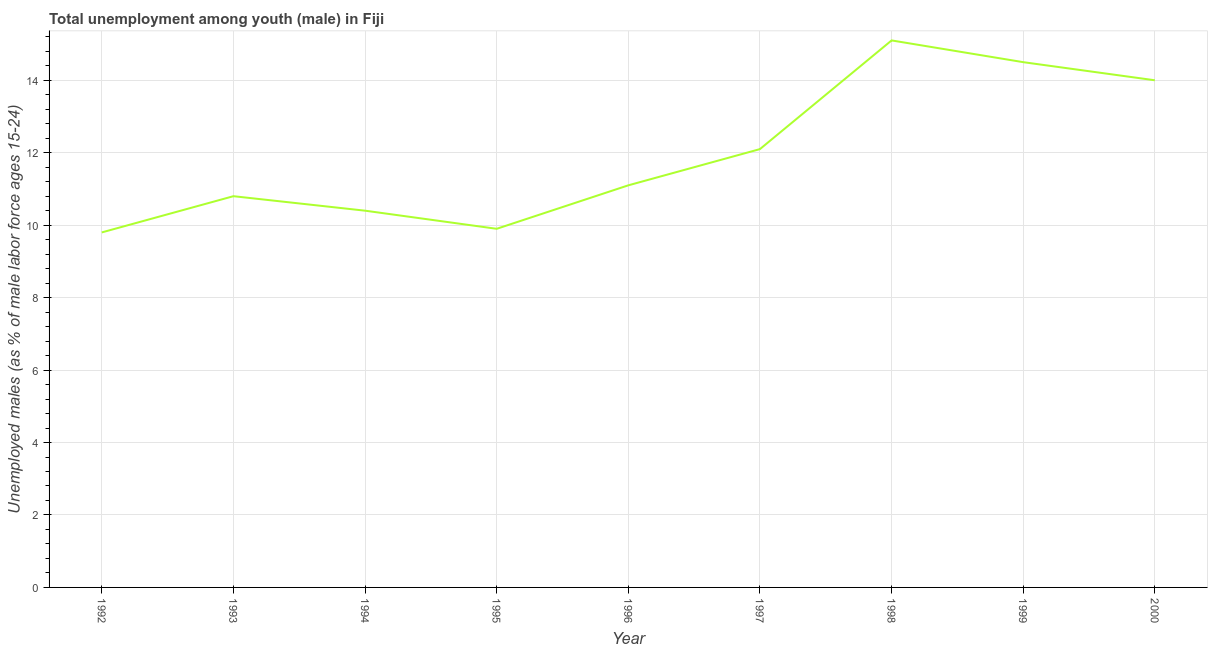What is the unemployed male youth population in 1992?
Make the answer very short. 9.8. Across all years, what is the maximum unemployed male youth population?
Offer a terse response. 15.1. Across all years, what is the minimum unemployed male youth population?
Give a very brief answer. 9.8. In which year was the unemployed male youth population maximum?
Provide a short and direct response. 1998. In which year was the unemployed male youth population minimum?
Your answer should be compact. 1992. What is the sum of the unemployed male youth population?
Your answer should be compact. 107.7. What is the difference between the unemployed male youth population in 1992 and 1994?
Your answer should be compact. -0.6. What is the average unemployed male youth population per year?
Offer a very short reply. 11.97. What is the median unemployed male youth population?
Provide a succinct answer. 11.1. What is the ratio of the unemployed male youth population in 1993 to that in 2000?
Your answer should be compact. 0.77. What is the difference between the highest and the second highest unemployed male youth population?
Offer a very short reply. 0.6. What is the difference between the highest and the lowest unemployed male youth population?
Give a very brief answer. 5.3. In how many years, is the unemployed male youth population greater than the average unemployed male youth population taken over all years?
Your answer should be very brief. 4. How many years are there in the graph?
Make the answer very short. 9. What is the difference between two consecutive major ticks on the Y-axis?
Provide a succinct answer. 2. Are the values on the major ticks of Y-axis written in scientific E-notation?
Provide a succinct answer. No. Does the graph contain any zero values?
Offer a terse response. No. What is the title of the graph?
Offer a terse response. Total unemployment among youth (male) in Fiji. What is the label or title of the Y-axis?
Ensure brevity in your answer.  Unemployed males (as % of male labor force ages 15-24). What is the Unemployed males (as % of male labor force ages 15-24) in 1992?
Your response must be concise. 9.8. What is the Unemployed males (as % of male labor force ages 15-24) in 1993?
Ensure brevity in your answer.  10.8. What is the Unemployed males (as % of male labor force ages 15-24) in 1994?
Your answer should be very brief. 10.4. What is the Unemployed males (as % of male labor force ages 15-24) of 1995?
Your response must be concise. 9.9. What is the Unemployed males (as % of male labor force ages 15-24) of 1996?
Your answer should be very brief. 11.1. What is the Unemployed males (as % of male labor force ages 15-24) in 1997?
Keep it short and to the point. 12.1. What is the Unemployed males (as % of male labor force ages 15-24) of 1998?
Your answer should be compact. 15.1. What is the difference between the Unemployed males (as % of male labor force ages 15-24) in 1992 and 1994?
Keep it short and to the point. -0.6. What is the difference between the Unemployed males (as % of male labor force ages 15-24) in 1992 and 1996?
Make the answer very short. -1.3. What is the difference between the Unemployed males (as % of male labor force ages 15-24) in 1992 and 1997?
Your answer should be very brief. -2.3. What is the difference between the Unemployed males (as % of male labor force ages 15-24) in 1992 and 1998?
Offer a very short reply. -5.3. What is the difference between the Unemployed males (as % of male labor force ages 15-24) in 1992 and 1999?
Offer a very short reply. -4.7. What is the difference between the Unemployed males (as % of male labor force ages 15-24) in 1993 and 1996?
Provide a succinct answer. -0.3. What is the difference between the Unemployed males (as % of male labor force ages 15-24) in 1993 and 1997?
Your answer should be compact. -1.3. What is the difference between the Unemployed males (as % of male labor force ages 15-24) in 1993 and 1998?
Your response must be concise. -4.3. What is the difference between the Unemployed males (as % of male labor force ages 15-24) in 1994 and 1998?
Provide a succinct answer. -4.7. What is the difference between the Unemployed males (as % of male labor force ages 15-24) in 1994 and 1999?
Keep it short and to the point. -4.1. What is the difference between the Unemployed males (as % of male labor force ages 15-24) in 1995 and 1998?
Offer a terse response. -5.2. What is the difference between the Unemployed males (as % of male labor force ages 15-24) in 1995 and 2000?
Offer a terse response. -4.1. What is the difference between the Unemployed males (as % of male labor force ages 15-24) in 1996 and 1997?
Make the answer very short. -1. What is the difference between the Unemployed males (as % of male labor force ages 15-24) in 1996 and 1998?
Your response must be concise. -4. What is the difference between the Unemployed males (as % of male labor force ages 15-24) in 1996 and 1999?
Your answer should be very brief. -3.4. What is the difference between the Unemployed males (as % of male labor force ages 15-24) in 1996 and 2000?
Offer a terse response. -2.9. What is the difference between the Unemployed males (as % of male labor force ages 15-24) in 1997 and 1999?
Keep it short and to the point. -2.4. What is the difference between the Unemployed males (as % of male labor force ages 15-24) in 1999 and 2000?
Keep it short and to the point. 0.5. What is the ratio of the Unemployed males (as % of male labor force ages 15-24) in 1992 to that in 1993?
Ensure brevity in your answer.  0.91. What is the ratio of the Unemployed males (as % of male labor force ages 15-24) in 1992 to that in 1994?
Your answer should be very brief. 0.94. What is the ratio of the Unemployed males (as % of male labor force ages 15-24) in 1992 to that in 1995?
Ensure brevity in your answer.  0.99. What is the ratio of the Unemployed males (as % of male labor force ages 15-24) in 1992 to that in 1996?
Offer a very short reply. 0.88. What is the ratio of the Unemployed males (as % of male labor force ages 15-24) in 1992 to that in 1997?
Offer a very short reply. 0.81. What is the ratio of the Unemployed males (as % of male labor force ages 15-24) in 1992 to that in 1998?
Your answer should be compact. 0.65. What is the ratio of the Unemployed males (as % of male labor force ages 15-24) in 1992 to that in 1999?
Provide a short and direct response. 0.68. What is the ratio of the Unemployed males (as % of male labor force ages 15-24) in 1992 to that in 2000?
Keep it short and to the point. 0.7. What is the ratio of the Unemployed males (as % of male labor force ages 15-24) in 1993 to that in 1994?
Your answer should be very brief. 1.04. What is the ratio of the Unemployed males (as % of male labor force ages 15-24) in 1993 to that in 1995?
Keep it short and to the point. 1.09. What is the ratio of the Unemployed males (as % of male labor force ages 15-24) in 1993 to that in 1997?
Ensure brevity in your answer.  0.89. What is the ratio of the Unemployed males (as % of male labor force ages 15-24) in 1993 to that in 1998?
Offer a very short reply. 0.71. What is the ratio of the Unemployed males (as % of male labor force ages 15-24) in 1993 to that in 1999?
Your response must be concise. 0.74. What is the ratio of the Unemployed males (as % of male labor force ages 15-24) in 1993 to that in 2000?
Keep it short and to the point. 0.77. What is the ratio of the Unemployed males (as % of male labor force ages 15-24) in 1994 to that in 1995?
Your response must be concise. 1.05. What is the ratio of the Unemployed males (as % of male labor force ages 15-24) in 1994 to that in 1996?
Give a very brief answer. 0.94. What is the ratio of the Unemployed males (as % of male labor force ages 15-24) in 1994 to that in 1997?
Give a very brief answer. 0.86. What is the ratio of the Unemployed males (as % of male labor force ages 15-24) in 1994 to that in 1998?
Your answer should be compact. 0.69. What is the ratio of the Unemployed males (as % of male labor force ages 15-24) in 1994 to that in 1999?
Make the answer very short. 0.72. What is the ratio of the Unemployed males (as % of male labor force ages 15-24) in 1994 to that in 2000?
Keep it short and to the point. 0.74. What is the ratio of the Unemployed males (as % of male labor force ages 15-24) in 1995 to that in 1996?
Your response must be concise. 0.89. What is the ratio of the Unemployed males (as % of male labor force ages 15-24) in 1995 to that in 1997?
Offer a terse response. 0.82. What is the ratio of the Unemployed males (as % of male labor force ages 15-24) in 1995 to that in 1998?
Your answer should be compact. 0.66. What is the ratio of the Unemployed males (as % of male labor force ages 15-24) in 1995 to that in 1999?
Provide a succinct answer. 0.68. What is the ratio of the Unemployed males (as % of male labor force ages 15-24) in 1995 to that in 2000?
Make the answer very short. 0.71. What is the ratio of the Unemployed males (as % of male labor force ages 15-24) in 1996 to that in 1997?
Keep it short and to the point. 0.92. What is the ratio of the Unemployed males (as % of male labor force ages 15-24) in 1996 to that in 1998?
Keep it short and to the point. 0.73. What is the ratio of the Unemployed males (as % of male labor force ages 15-24) in 1996 to that in 1999?
Provide a short and direct response. 0.77. What is the ratio of the Unemployed males (as % of male labor force ages 15-24) in 1996 to that in 2000?
Keep it short and to the point. 0.79. What is the ratio of the Unemployed males (as % of male labor force ages 15-24) in 1997 to that in 1998?
Provide a short and direct response. 0.8. What is the ratio of the Unemployed males (as % of male labor force ages 15-24) in 1997 to that in 1999?
Make the answer very short. 0.83. What is the ratio of the Unemployed males (as % of male labor force ages 15-24) in 1997 to that in 2000?
Keep it short and to the point. 0.86. What is the ratio of the Unemployed males (as % of male labor force ages 15-24) in 1998 to that in 1999?
Make the answer very short. 1.04. What is the ratio of the Unemployed males (as % of male labor force ages 15-24) in 1998 to that in 2000?
Your answer should be compact. 1.08. What is the ratio of the Unemployed males (as % of male labor force ages 15-24) in 1999 to that in 2000?
Your answer should be very brief. 1.04. 